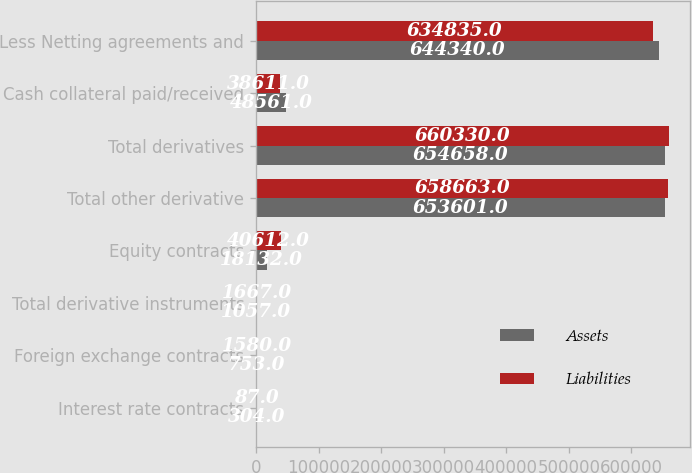<chart> <loc_0><loc_0><loc_500><loc_500><stacked_bar_chart><ecel><fcel>Interest rate contracts<fcel>Foreign exchange contracts<fcel>Total derivative instruments<fcel>Equity contracts<fcel>Total other derivative<fcel>Total derivatives<fcel>Cash collateral paid/received<fcel>Less Netting agreements and<nl><fcel>Assets<fcel>304<fcel>753<fcel>1057<fcel>18132<fcel>653601<fcel>654658<fcel>48561<fcel>644340<nl><fcel>Liabilities<fcel>87<fcel>1580<fcel>1667<fcel>40612<fcel>658663<fcel>660330<fcel>38611<fcel>634835<nl></chart> 